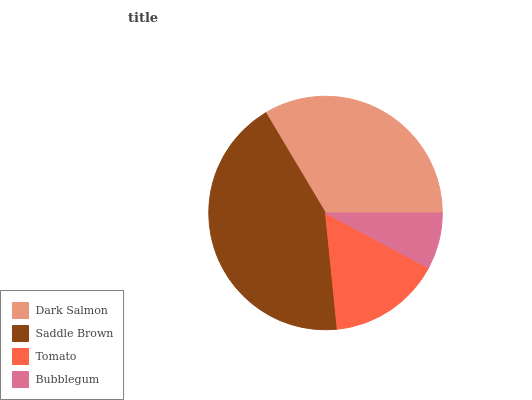Is Bubblegum the minimum?
Answer yes or no. Yes. Is Saddle Brown the maximum?
Answer yes or no. Yes. Is Tomato the minimum?
Answer yes or no. No. Is Tomato the maximum?
Answer yes or no. No. Is Saddle Brown greater than Tomato?
Answer yes or no. Yes. Is Tomato less than Saddle Brown?
Answer yes or no. Yes. Is Tomato greater than Saddle Brown?
Answer yes or no. No. Is Saddle Brown less than Tomato?
Answer yes or no. No. Is Dark Salmon the high median?
Answer yes or no. Yes. Is Tomato the low median?
Answer yes or no. Yes. Is Saddle Brown the high median?
Answer yes or no. No. Is Dark Salmon the low median?
Answer yes or no. No. 